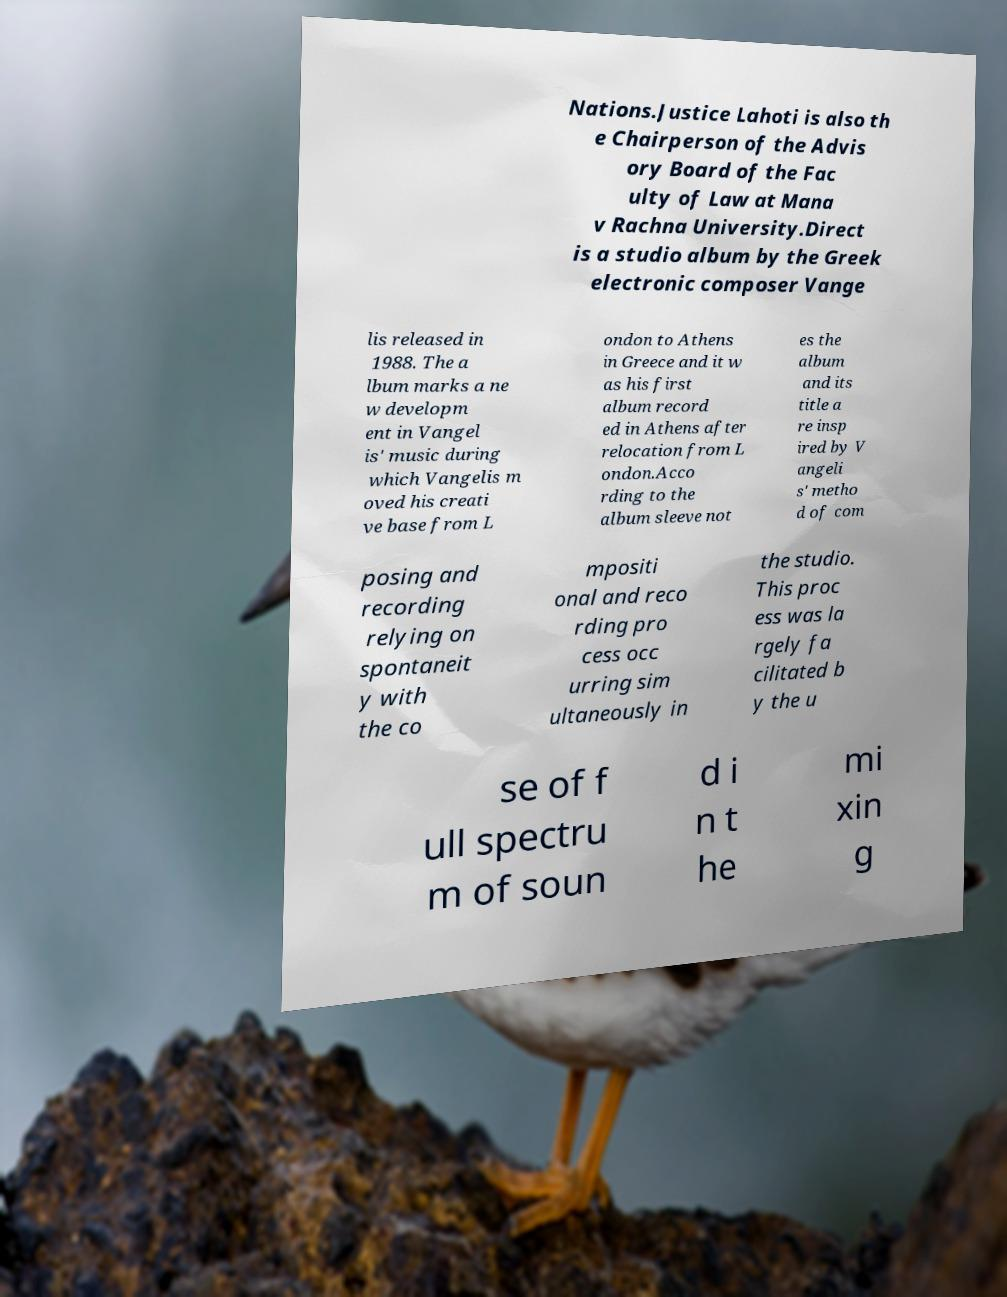Can you accurately transcribe the text from the provided image for me? Nations.Justice Lahoti is also th e Chairperson of the Advis ory Board of the Fac ulty of Law at Mana v Rachna University.Direct is a studio album by the Greek electronic composer Vange lis released in 1988. The a lbum marks a ne w developm ent in Vangel is' music during which Vangelis m oved his creati ve base from L ondon to Athens in Greece and it w as his first album record ed in Athens after relocation from L ondon.Acco rding to the album sleeve not es the album and its title a re insp ired by V angeli s' metho d of com posing and recording relying on spontaneit y with the co mpositi onal and reco rding pro cess occ urring sim ultaneously in the studio. This proc ess was la rgely fa cilitated b y the u se of f ull spectru m of soun d i n t he mi xin g 